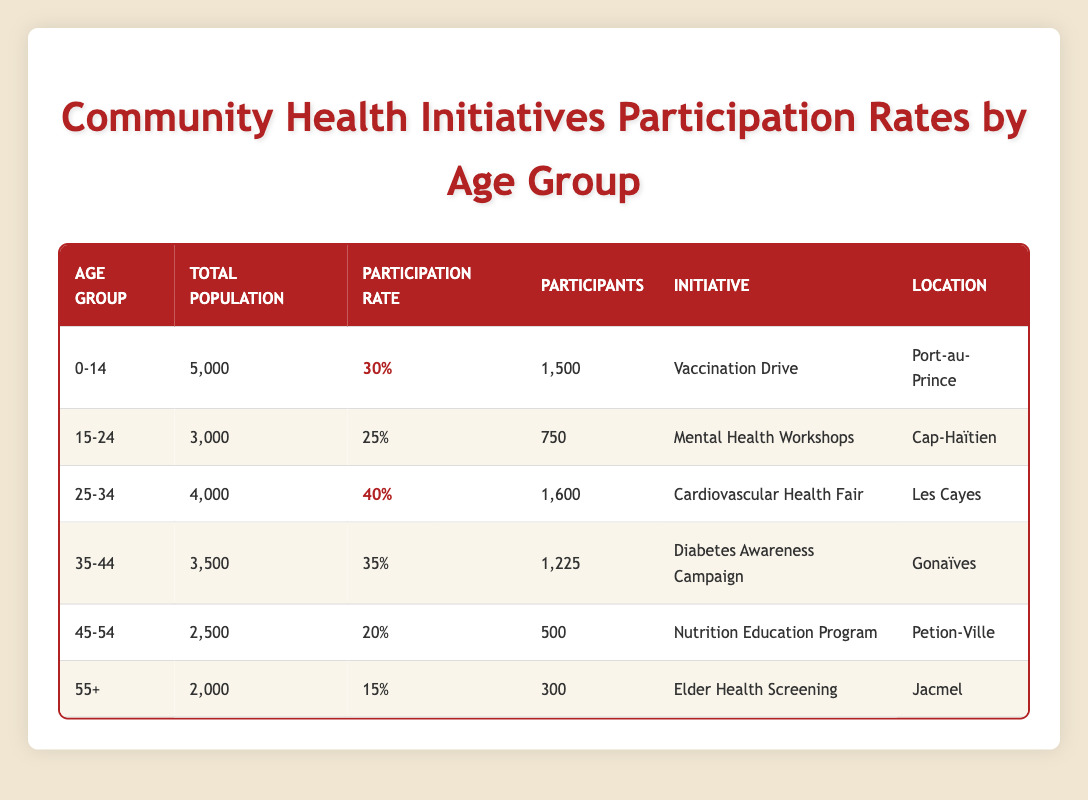What is the total number of participants in the Vaccination Drive initiative? According to the table, the number of participants in the Vaccination Drive initiative for the age group 0-14 is listed as 1,500.
Answer: 1,500 Which age group has the highest participation rate? The age group 25-34 has the highest participation rate at 40%, as indicated in the table.
Answer: 25-34 How many participants were involved in the Diabetes Awareness Campaign? The table shows that the Diabetes Awareness Campaign had 1,225 participants in the age group 35-44.
Answer: 1,225 What is the participation rate for the age group 45-54? The table lists the participation rate for the age group 45-54 as 20%.
Answer: 20% True or False: The total population in the 55+ age group is higher than that in the 15-24 age group. The total population in the 55+ age group is 2,000 whereas in the 15-24 age group it is 3,000, so this statement is false.
Answer: False What is the sum of participants in the Vaccination Drive and the Cardiovascular Health Fair? Adding the participants from both initiatives, 1,500 (Vaccination Drive) + 1,600 (Cardiovascular Health Fair) equals 3,100.
Answer: 3,100 What is the average participation rate of the initiatives for all age groups? The participation rates are 30%, 25%, 40%, 35%, 20%, and 15%. The sum is 30 + 25 + 40 + 35 + 20 + 15 = 165, and the average is 165/6 = 27.5%.
Answer: 27.5% Which location had the initiative with the lowest number of participants? The Elder Health Screening in Jacmel had the lowest number of participants at 300, as shown in the table.
Answer: Jacmel If the total population in the age group 35-44 is subtracted from the total population in the age group 25-34, what is the result? The total population for age group 25-34 is 4,000, and for 35-44 it is 3,500. The difference is 4,000 - 3,500 = 500.
Answer: 500 Which initiative had a lower participation rate: the Nutrition Education Program or the Elder Health Screening? The Nutrition Education Program had a participation rate of 20%, while the Elder Health Screening had a participation rate of 15%. Therefore, the Elder Health Screening had the lower participation rate.
Answer: Elder Health Screening 